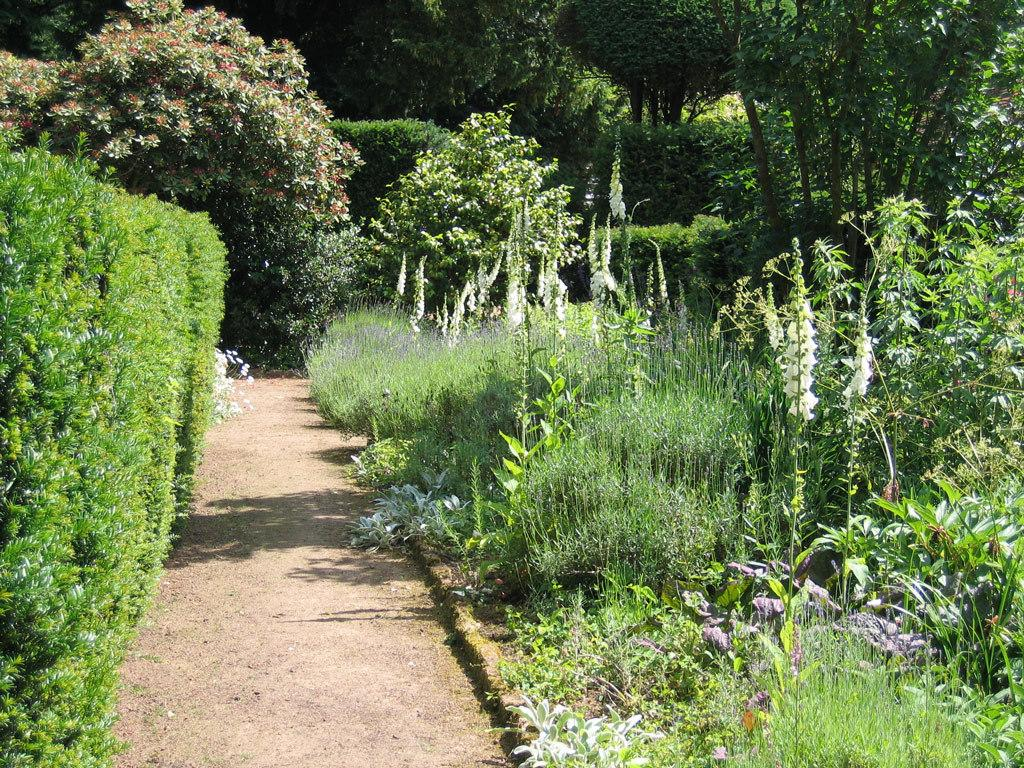What type of vegetation can be seen in the image? There are plants and flowers in the image. What else can be seen in the image besides the plants and flowers? There is a path in the image. What is visible in the background of the image? There are trees in the background of the image. What type of bun is being used to hold the flowers in the image? There is no bun present in the image; the flowers are not being held by any bun. 